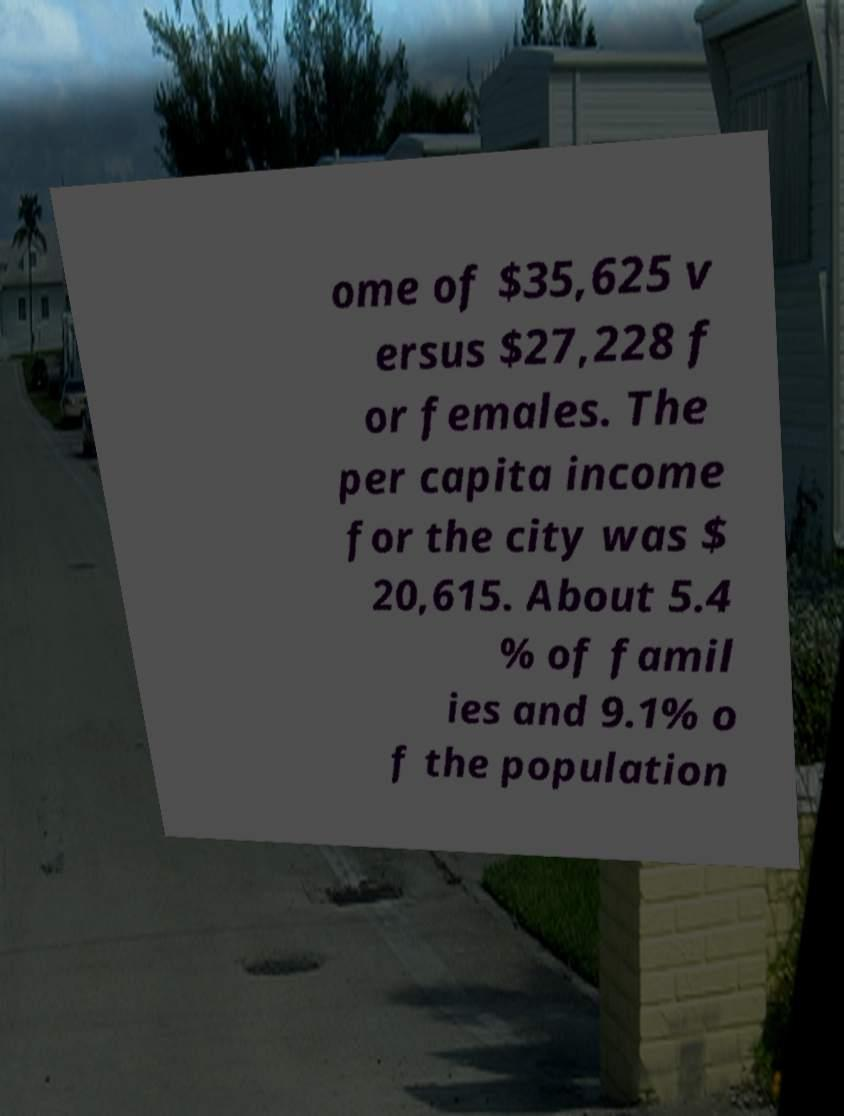Could you assist in decoding the text presented in this image and type it out clearly? ome of $35,625 v ersus $27,228 f or females. The per capita income for the city was $ 20,615. About 5.4 % of famil ies and 9.1% o f the population 